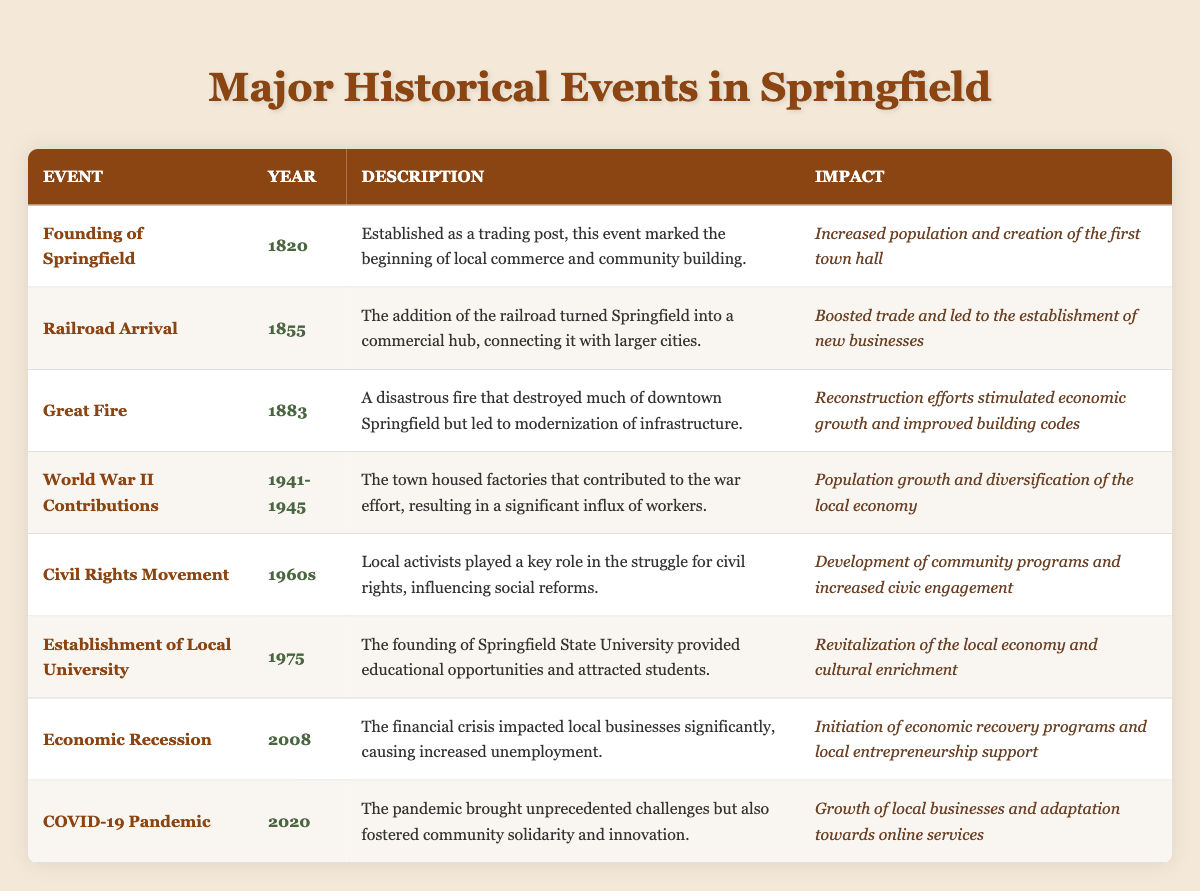What year was the Great Fire in Springfield? According to the table, the Great Fire occurred in the year 1883.
Answer: 1883 What event led to a significant influx of workers in Springfield? The table specifies that the World War II Contributions led to a significant influx of workers due to the housing of factories for the war effort.
Answer: World War II Contributions What was the impact of the railroad arrival in 1855? The table notes that the impact of the railroad arrival was a boost in trade and the establishment of new businesses.
Answer: Boosted trade and led to new businesses Which event occurred between 1941 and 1945? The table indicates that the World War II Contributions spanned from 1941 to 1945.
Answer: World War II Contributions Was there an event that caused the first town hall to be created? Yes, the Founding of Springfield resulted in the creation of the first town hall.
Answer: Yes How many significant events took place before 1900? By reviewing the table, there are three significant events listed before 1900: Founding of Springfield (1820), Railroad Arrival (1855), and Great Fire (1883).
Answer: Three What were the two impacts of the Great Fire? The Great Fire led to modernization of infrastructure and stimulated economic growth through reconstruction efforts.
Answer: Modernization of infrastructure and economic growth What was the local reaction to the COVID-19 pandemic? The community demonstrated solidarity and innovation in response to the challenges posed by COVID-19, as reflected in the table's description of the event.
Answer: Solidarity and innovation In what year was the local university established? The table explicitly states that the establishment of the local university occurred in 1975.
Answer: 1975 Which event had a direct impact on local businesses in 2008? The Economic Recession in 2008 directly impacted local businesses, as described in the table.
Answer: Economic Recession What is the trend of population growth in Springfield following the significant events? Analysis of the table reveals that events such as the Founding of Springfield, World War II Contributions, and others contribute to trends in population growth and diversification over time.
Answer: Population growth trend Did the Civil Rights Movement lead to increased civic engagement? Yes, according to the table, the Civil Rights Movement led to increased civic engagement and the development of community programs.
Answer: Yes What major event caused economic recovery programs to be initiated? The Economic Recession in 2008 led to the initiation of economic recovery programs.
Answer: Economic Recession 